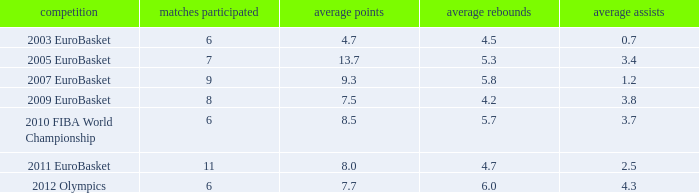How many points per game have the tournament 2005 eurobasket? 13.7. 